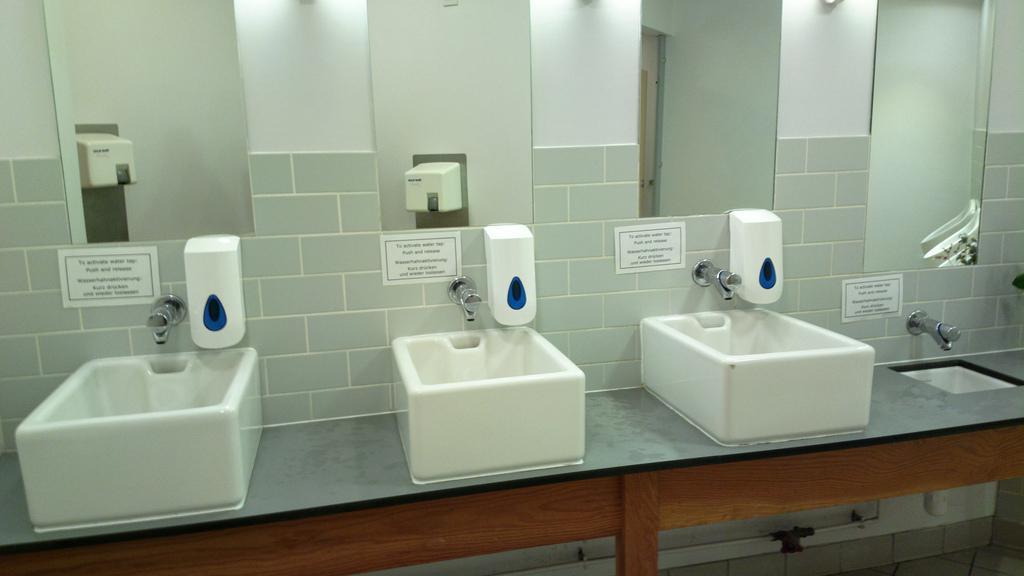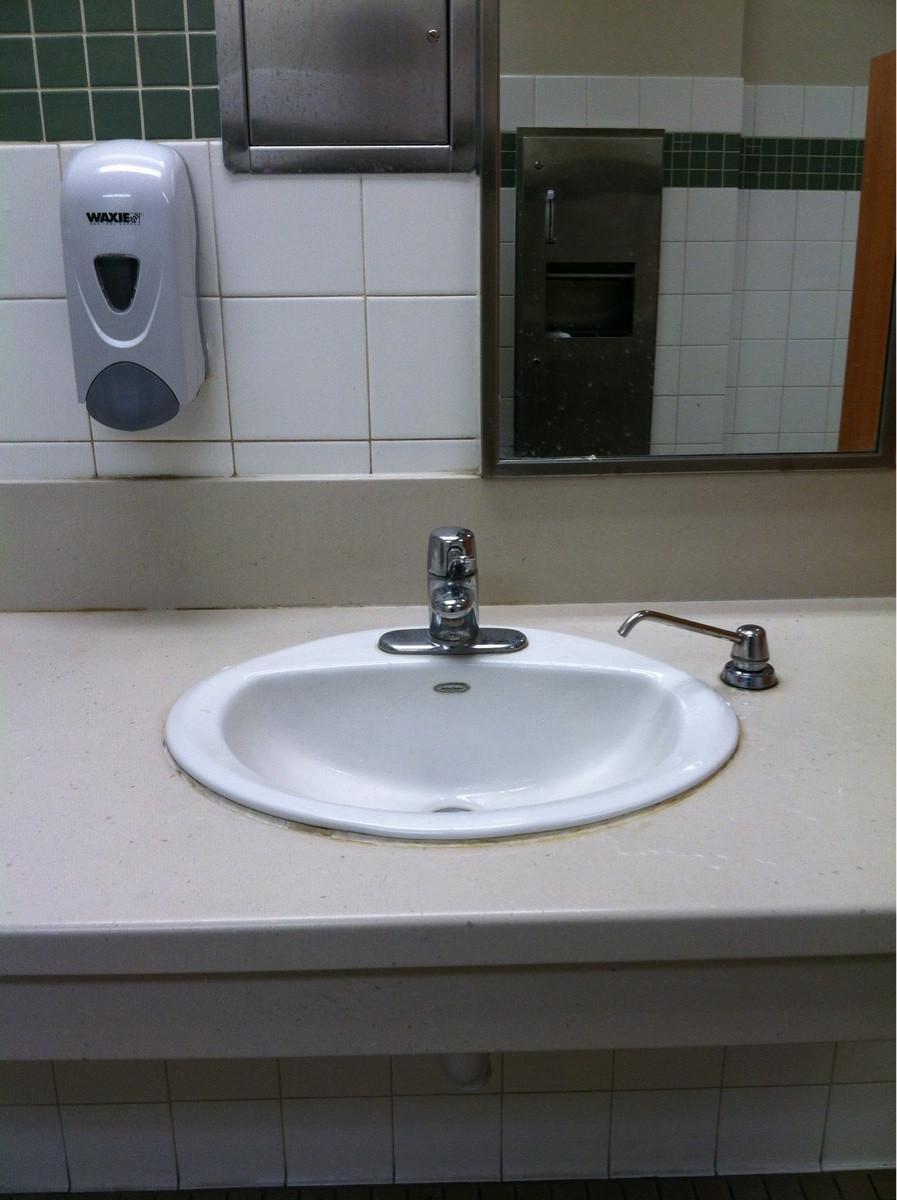The first image is the image on the left, the second image is the image on the right. Assess this claim about the two images: "In at least one image, a human hand is visible interacting with a soap dispenser". Correct or not? Answer yes or no. No. The first image is the image on the left, the second image is the image on the right. Assess this claim about the two images: "The right image contains at least two sinks.". Correct or not? Answer yes or no. No. 